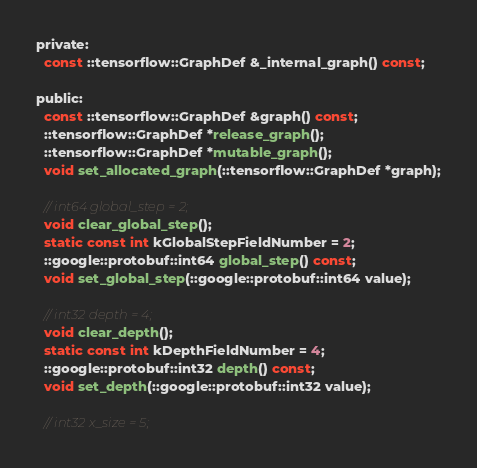Convert code to text. <code><loc_0><loc_0><loc_500><loc_500><_C_>
private:
  const ::tensorflow::GraphDef &_internal_graph() const;

public:
  const ::tensorflow::GraphDef &graph() const;
  ::tensorflow::GraphDef *release_graph();
  ::tensorflow::GraphDef *mutable_graph();
  void set_allocated_graph(::tensorflow::GraphDef *graph);

  // int64 global_step = 2;
  void clear_global_step();
  static const int kGlobalStepFieldNumber = 2;
  ::google::protobuf::int64 global_step() const;
  void set_global_step(::google::protobuf::int64 value);

  // int32 depth = 4;
  void clear_depth();
  static const int kDepthFieldNumber = 4;
  ::google::protobuf::int32 depth() const;
  void set_depth(::google::protobuf::int32 value);

  // int32 x_size = 5;</code> 